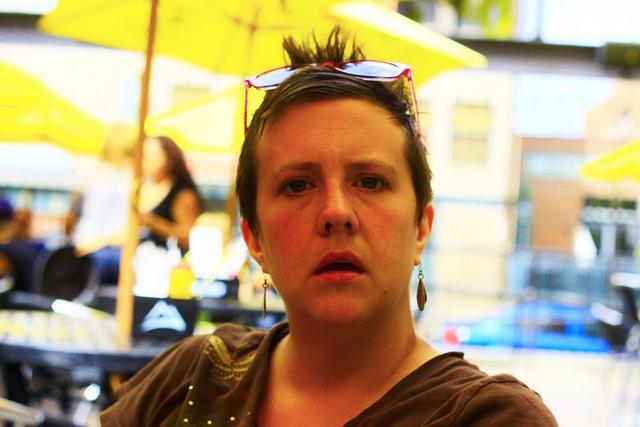Do her earrings match?
Keep it brief. Yes. How is she feeling?
Quick response, please. Confused. What is the woman wearing?
Short answer required. Sunglasses. 